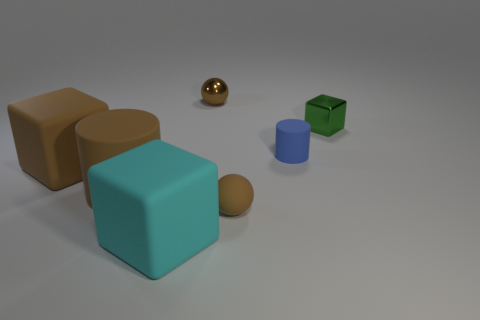Subtract all green blocks. How many blocks are left? 2 Subtract 1 cubes. How many cubes are left? 2 Add 1 metallic objects. How many objects exist? 8 Subtract all brown blocks. How many blocks are left? 2 Subtract all spheres. How many objects are left? 5 Subtract all blue cubes. Subtract all yellow spheres. How many cubes are left? 3 Add 3 large green matte objects. How many large green matte objects exist? 3 Subtract 0 purple cylinders. How many objects are left? 7 Subtract all blue things. Subtract all large yellow shiny balls. How many objects are left? 6 Add 1 tiny spheres. How many tiny spheres are left? 3 